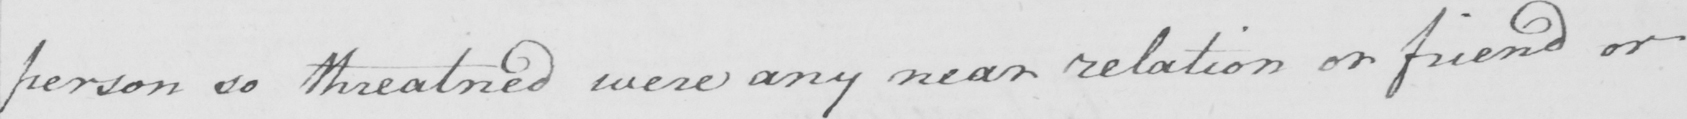What does this handwritten line say? person so threatned were any near relation or friend or 